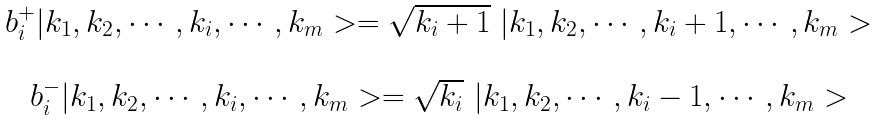Convert formula to latex. <formula><loc_0><loc_0><loc_500><loc_500>\begin{array} { c } b _ { i } ^ { + } | k _ { 1 } , k _ { 2 } , \cdots , k _ { i } , \cdots , k _ { m } > = \sqrt { k _ { i } + 1 } \ | k _ { 1 } , k _ { 2 } , \cdots , k _ { i } + 1 , \cdots , k _ { m } > \\ \\ b _ { i } ^ { - } | k _ { 1 } , k _ { 2 } , \cdots , k _ { i } , \cdots , k _ { m } > = \sqrt { k _ { i } } \ | k _ { 1 } , k _ { 2 } , \cdots , k _ { i } - 1 , \cdots , k _ { m } > \\ \end{array}</formula> 